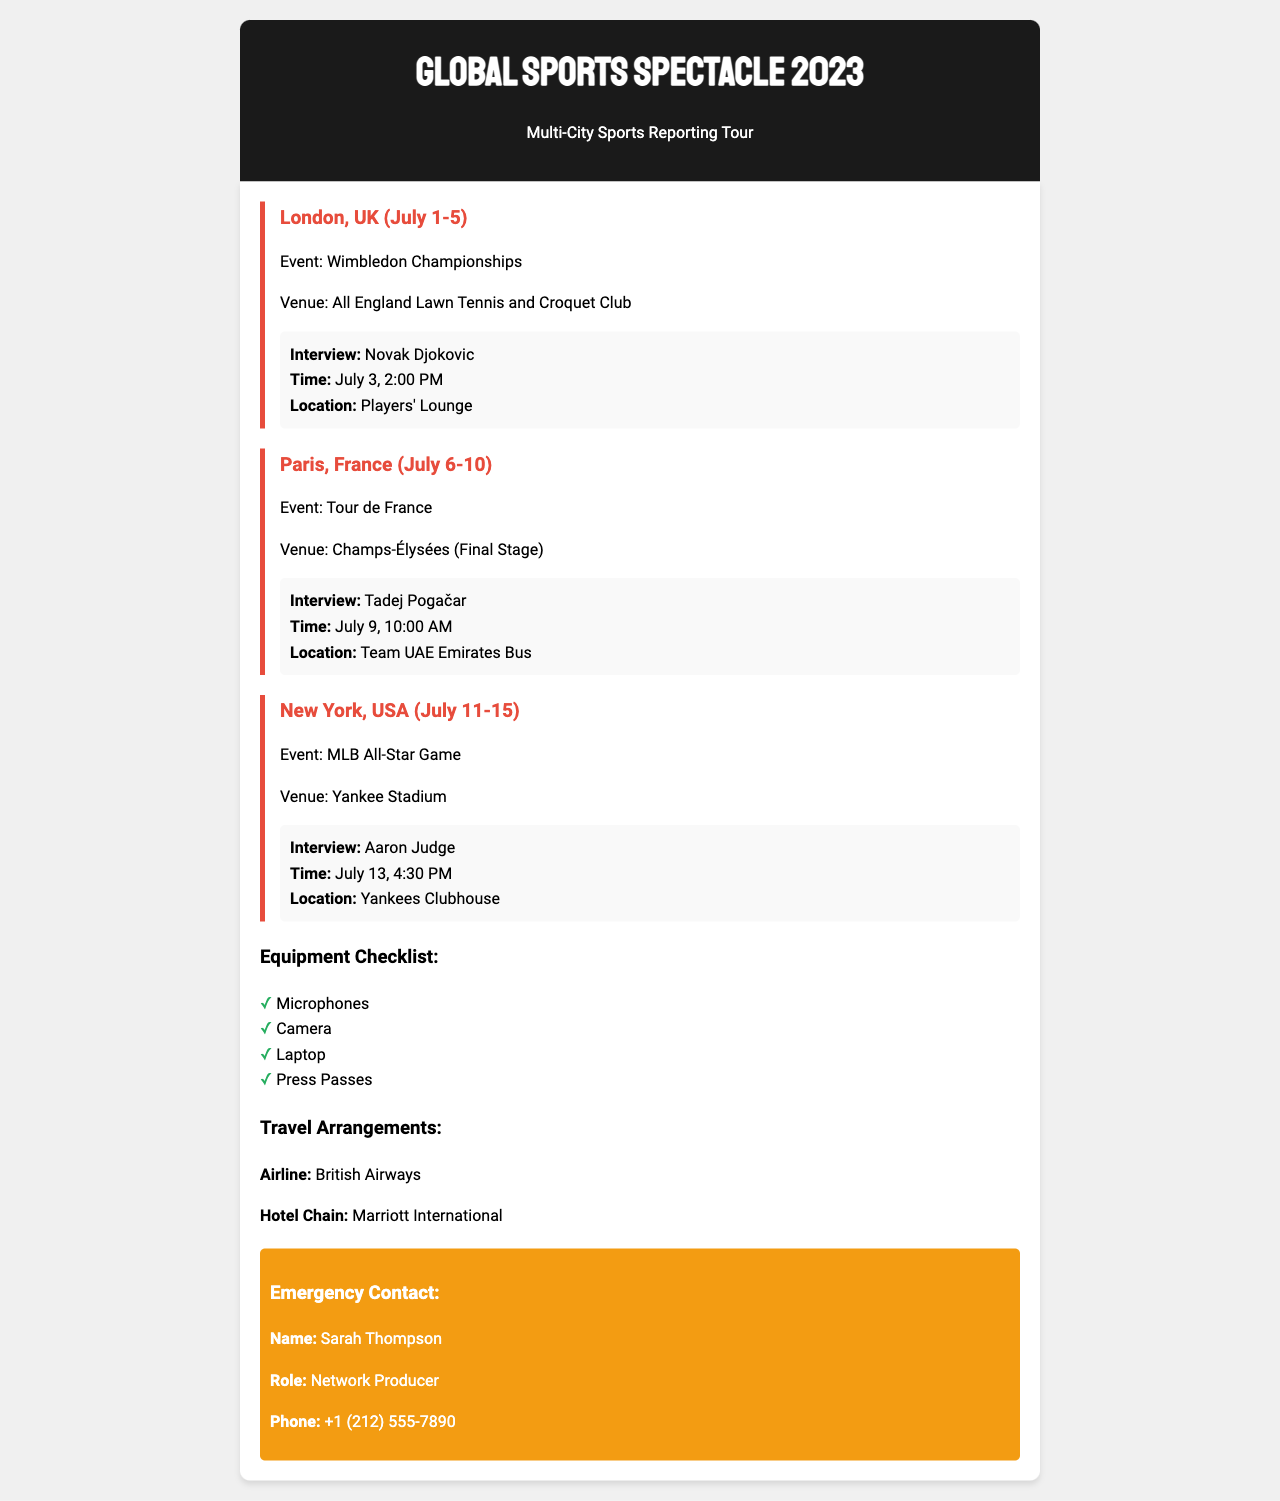What is the event in London? The document states that the event in London is the Wimbledon Championships.
Answer: Wimbledon Championships When is the interview with Novak Djokovic scheduled? The document specifies that the interview with Novak Djokovic is on July 3 at 2:00 PM.
Answer: July 3, 2:00 PM What venue is the Tour de France final stage held at? The venue for the Tour de France final stage mentioned in the document is Champs-Élysées.
Answer: Champs-Élysées Who is the emergency contact person? The document lists Sarah Thompson as the emergency contact person.
Answer: Sarah Thompson What city will the MLB All-Star Game take place? According to the document, the MLB All-Star Game will take place in New York, USA.
Answer: New York, USA How many cities are listed in the itinerary? The document outlines a multi-city tour that includes three cities: London, Paris, and New York.
Answer: Three Which airline is mentioned for travel arrangements? The document indicates that British Airways is the airline for travel arrangements.
Answer: British Airways What is the role of the emergency contact? The document states that Sarah Thompson is a Network Producer as the emergency contact.
Answer: Network Producer 